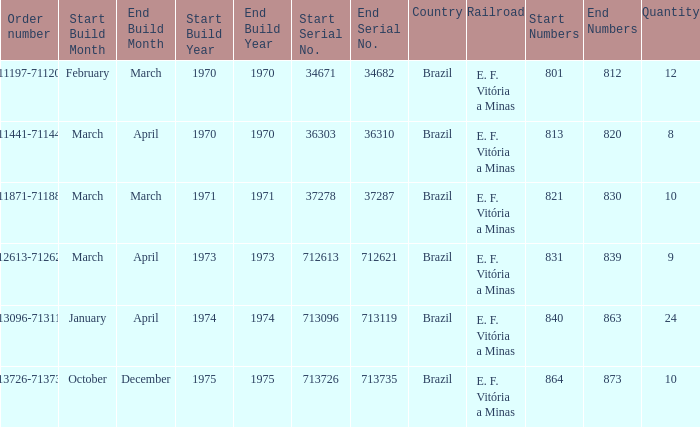What are the numbers for the order number 713096-713119? 840-863. 